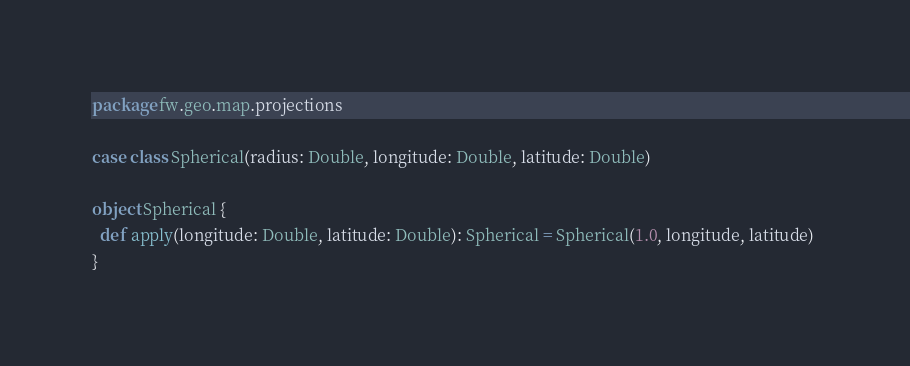Convert code to text. <code><loc_0><loc_0><loc_500><loc_500><_Scala_>package fw.geo.map.projections

case class Spherical(radius: Double, longitude: Double, latitude: Double)

object Spherical {
  def apply(longitude: Double, latitude: Double): Spherical = Spherical(1.0, longitude, latitude) 
}
</code> 